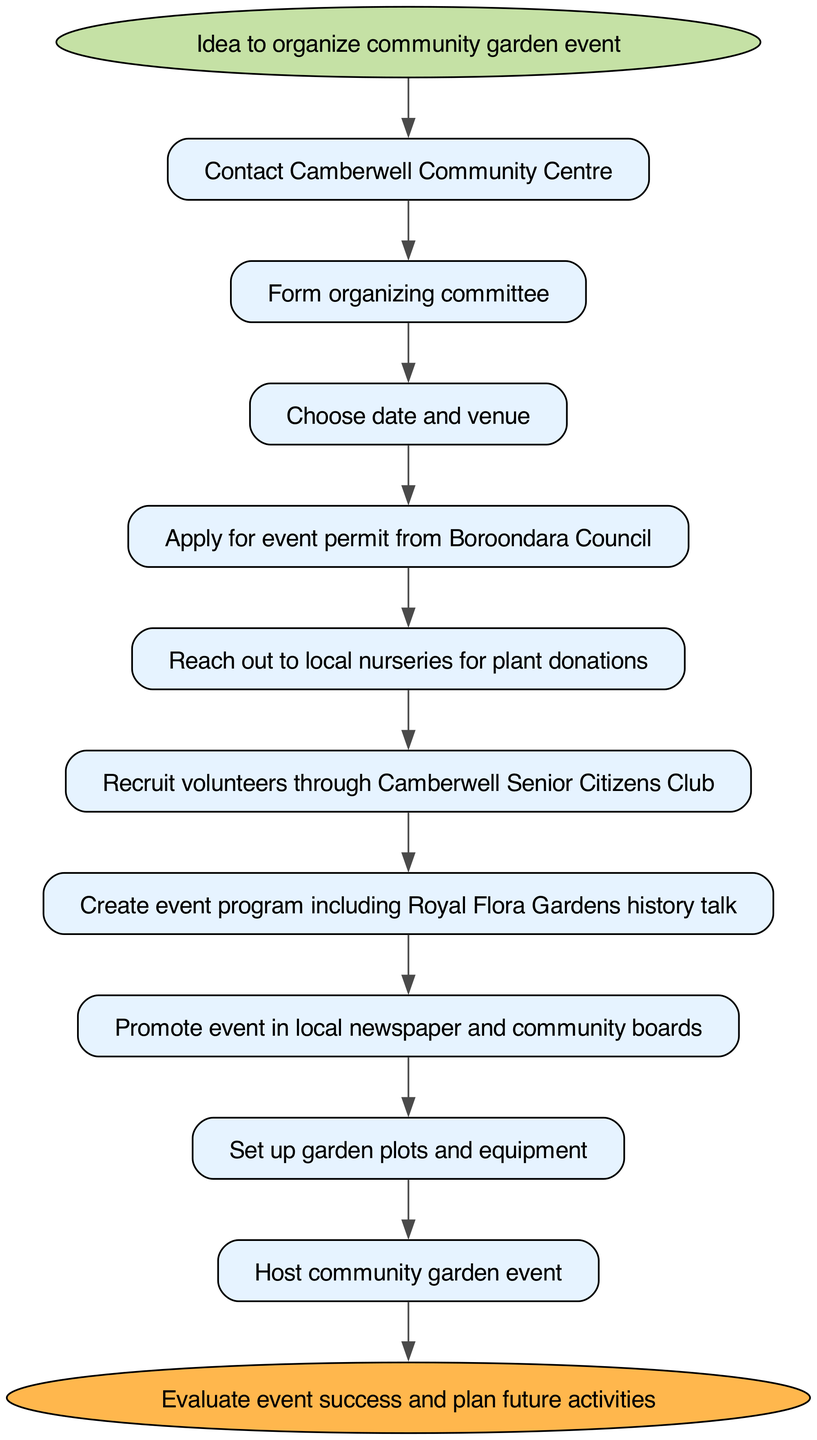What is the first step in organizing the community garden event? The first step, indicated in the diagram, is "Idea to organize community garden event." This is positioned at the top of the flowchart as the starting point.
Answer: Idea to organize community garden event How many nodes are there in total? By counting all the distinct steps in the flowchart, including the start and end nodes, there are 11 nodes in total.
Answer: 11 What comes after forming the organizing committee? According to the flowchart, after forming the organizing committee, the next step is "Choose date and venue." This is indicated by the arrow guiding the flow from the committee formation to the date and venue selection node.
Answer: Choose date and venue What is the significance of the "Royal Flora Gardens history talk"? The "Royal Flora Gardens history talk" is included in the "Create event program" step. Its significance lies in the cultural aspect it adds to the event, showing a connection to local history, which is highlighted in this specific node.
Answer: Cultural aspect What is the relationship between applying for an event permit and reaching out to local nurseries? The flowchart indicates that "Apply for event permit from Boroondara Council" must be completed before "Reach out to local nurseries for plant donations." This shows a sequential dependency in the organizing process.
Answer: Sequential dependency 